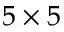<formula> <loc_0><loc_0><loc_500><loc_500>5 \times 5</formula> 